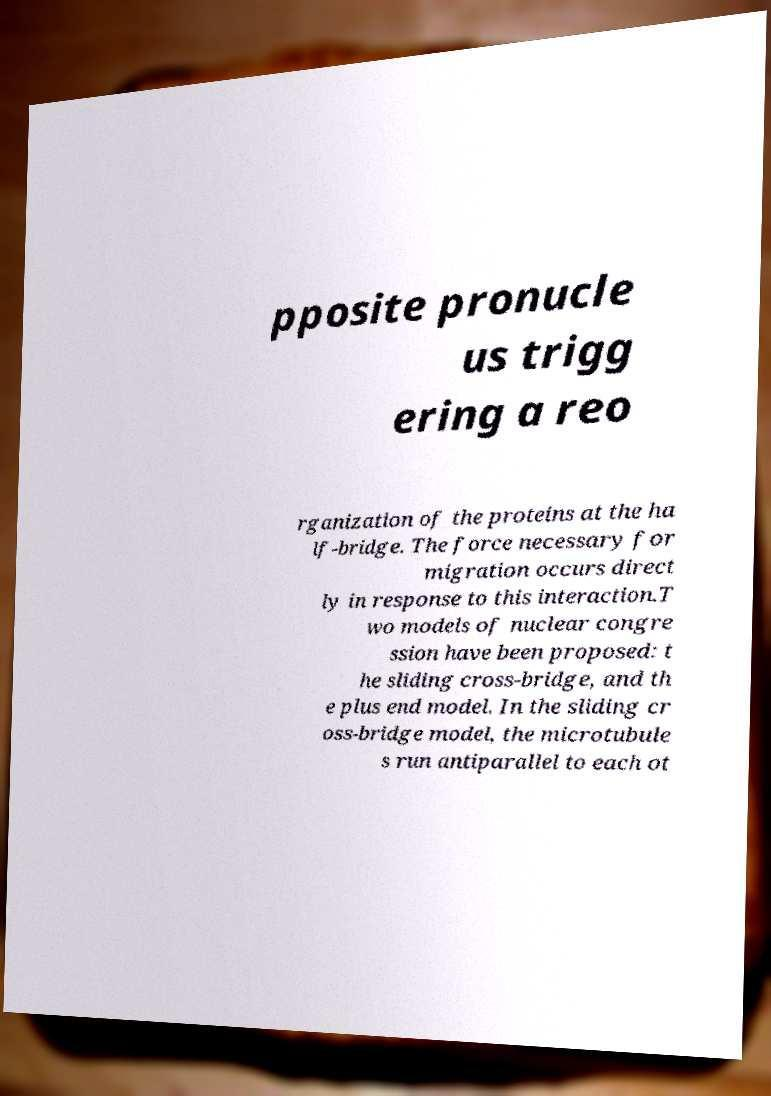Can you read and provide the text displayed in the image?This photo seems to have some interesting text. Can you extract and type it out for me? pposite pronucle us trigg ering a reo rganization of the proteins at the ha lf-bridge. The force necessary for migration occurs direct ly in response to this interaction.T wo models of nuclear congre ssion have been proposed: t he sliding cross-bridge, and th e plus end model. In the sliding cr oss-bridge model, the microtubule s run antiparallel to each ot 